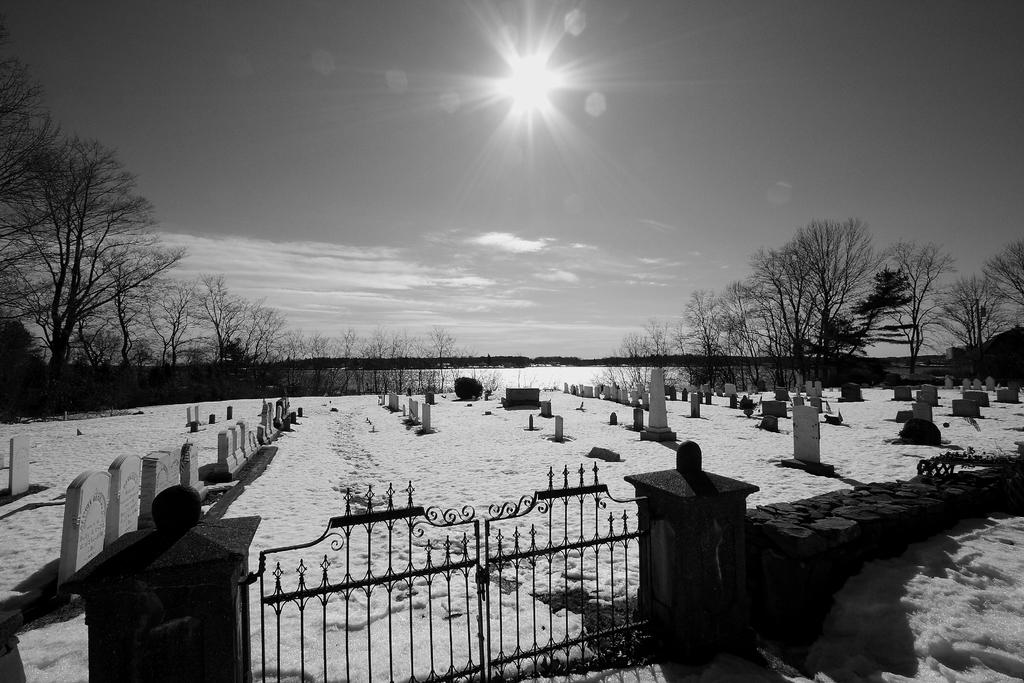What is the main subject in the foreground of the image? There is a cemetery in the foreground of the image. What can be seen in the background of the image? There are trees and water visible in the background of the image. What is the condition of the sky in the background of the image? The sun is observable in the sky in the background of the image. What type of yarn is being used to decorate the gravestones in the image? There is no yarn present in the image, and no decorations are mentioned on the gravestones. 